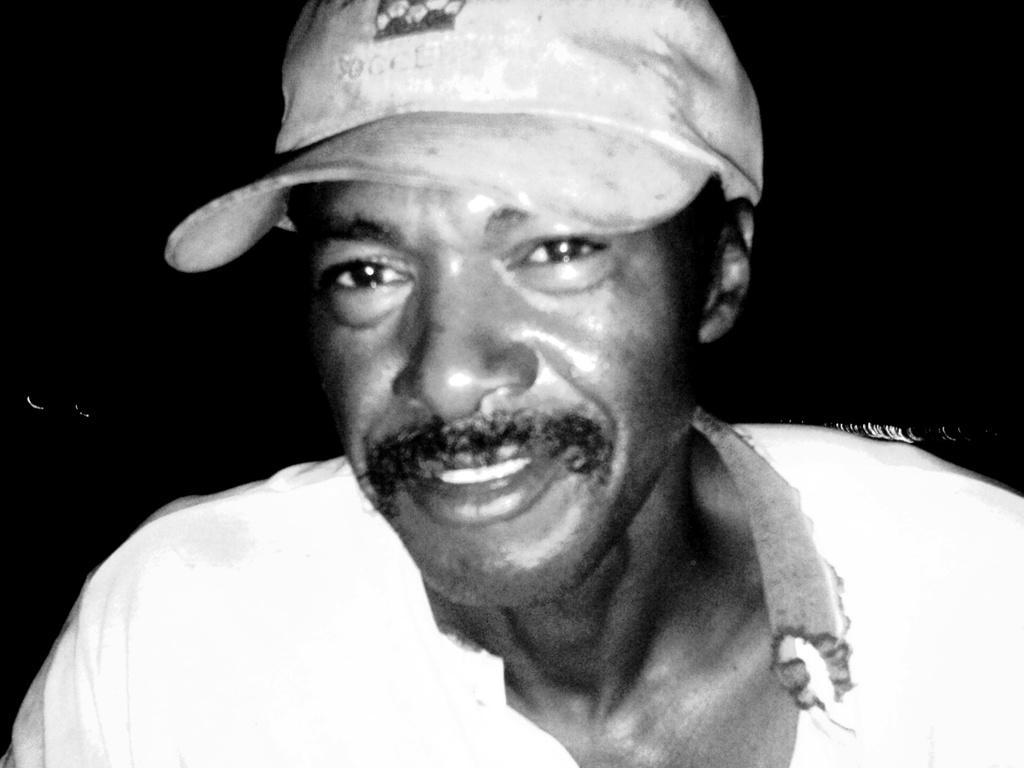Who is the main subject in the foreground of the image? There is a man in the foreground of the image. What is the man wearing on his head? The man is wearing a cap. What can be observed about the background of the image? The background of the image is very dark. What type of needle is the man using in the image? There is no needle present in the image; the man is wearing a cap and standing in a dark background. What kind of crook can be seen in the man's ear in the image? There is no crook or any object in the man's ear in the image; he is simply wearing a cap. 